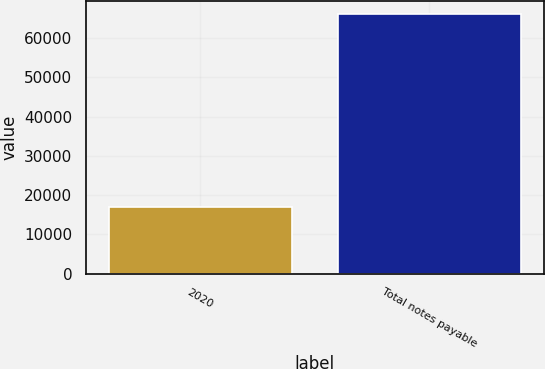Convert chart. <chart><loc_0><loc_0><loc_500><loc_500><bar_chart><fcel>2020<fcel>Total notes payable<nl><fcel>17043<fcel>66306<nl></chart> 